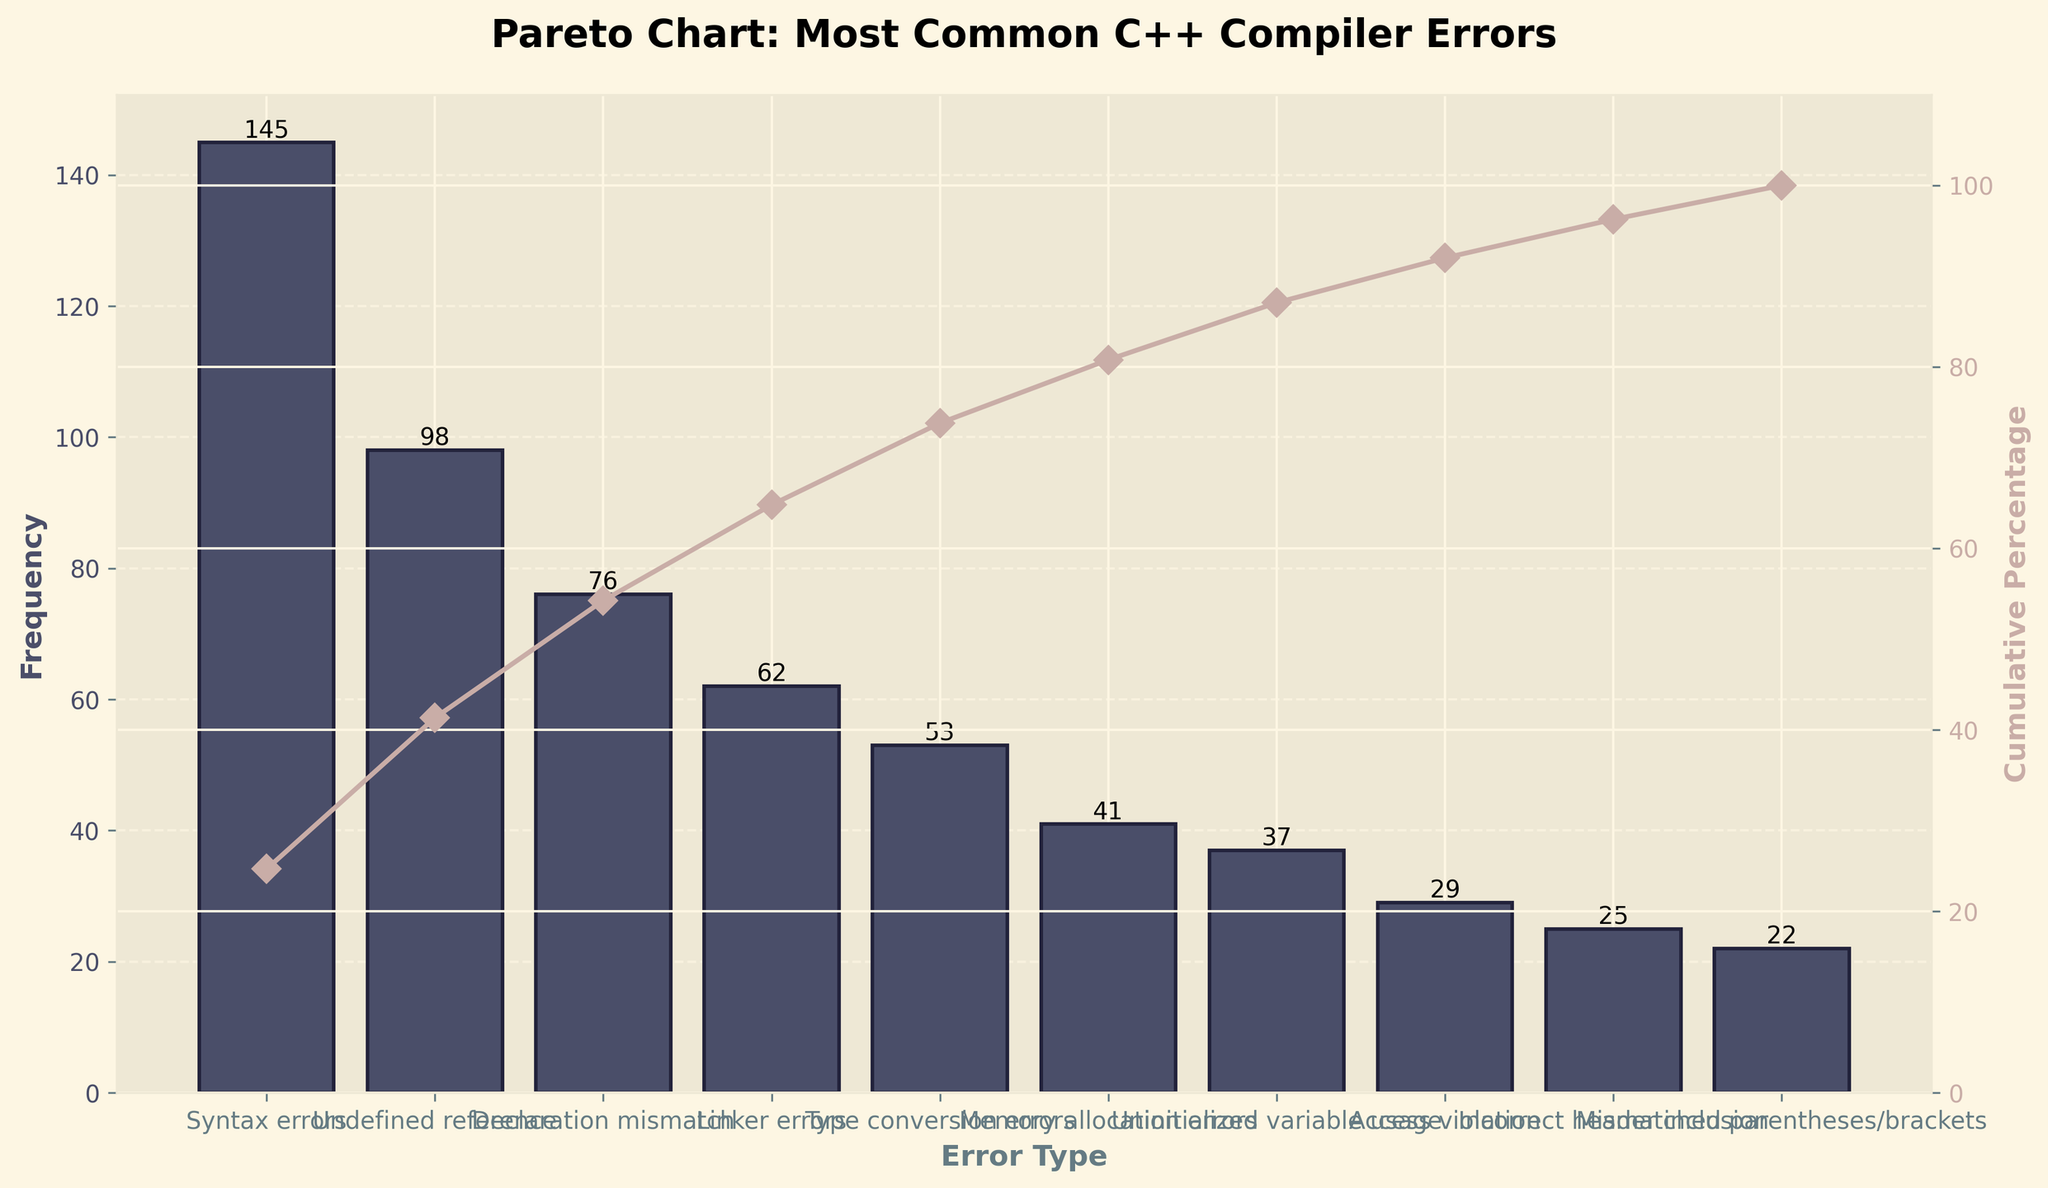What is the title of the plot? The title of the plot is usually the most prominent text at the top of the figure and describes what the chart is about. In this case, it is clearly shown at the top in bold letters.
Answer: Pareto Chart: Most Common C++ Compiler Errors How many types of errors are there in the data? To find the number of error types, count the individual bars on the bar chart. Each bar represents a unique error type.
Answer: 10 Which error type has the highest frequency? To find the error type with the highest frequency, look for the tallest bar on the chart and refer to its label on the x-axis.
Answer: Syntax errors What is the frequency of 'Type conversion errors'? Identify the bar labeled 'Type conversion errors' and read the height of that bar, which indicates its frequency.
Answer: 53 What is the cumulative percentage of ‘Undefined reference’ errors? Locate the point where 'Undefined reference' intersects the cumulative percentage curve and read the corresponding value on the secondary y-axis.
Answer: Approximately 54% What is the total frequency of all errors combined? Sum the frequencies of all error types by adding the height of each bar in the chart.
Answer: 588 How do 'Memory allocation errors' compare in frequency to 'Access violation'? Compare the heights of the bars labeled 'Memory allocation errors' and 'Access violation'. The height of each bar gives the respective error frequencies.
Answer: Memory allocation errors are more frequent than Access violations Which error types cumulatively account for approximately 80% of all errors? Look at the cumulative percentage curve and find where it intersects 80%. The error types up to this point are the ones cumulatively accounting for 80% of the errors.
Answer: Syntax errors, Undefined reference, Declaration mismatch, and Linker errors What is the cumulative percentage after including 'Memory allocation errors'? Locate the cumulative percentage value where the bar labeled 'Memory allocation errors' intersects the cumulative percentage curve and read the value on the secondary y-axis.
Answer: Approximately 73% Which error type has the lowest frequency, and what is it? Find the shortest bar on the chart, which represents the error type with the lowest frequency, and read its label from the x-axis.
Answer: Mismatched parentheses/brackets, 22 